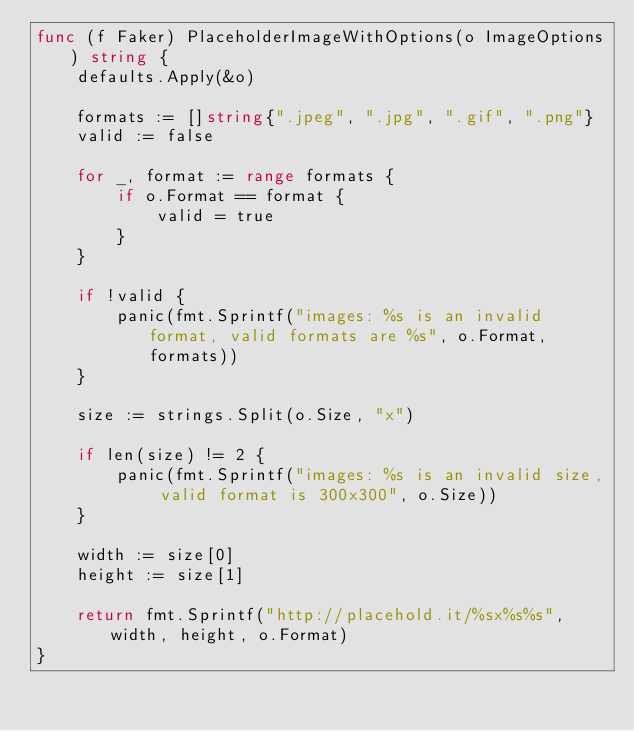Convert code to text. <code><loc_0><loc_0><loc_500><loc_500><_Go_>func (f Faker) PlaceholderImageWithOptions(o ImageOptions) string {
	defaults.Apply(&o)

	formats := []string{".jpeg", ".jpg", ".gif", ".png"}
	valid := false

	for _, format := range formats {
		if o.Format == format {
			valid = true
		}
	}

	if !valid {
		panic(fmt.Sprintf("images: %s is an invalid format, valid formats are %s", o.Format, formats))
	}

	size := strings.Split(o.Size, "x")

	if len(size) != 2 {
		panic(fmt.Sprintf("images: %s is an invalid size, valid format is 300x300", o.Size))
	}

	width := size[0]
	height := size[1]

	return fmt.Sprintf("http://placehold.it/%sx%s%s", width, height, o.Format)
}
</code> 